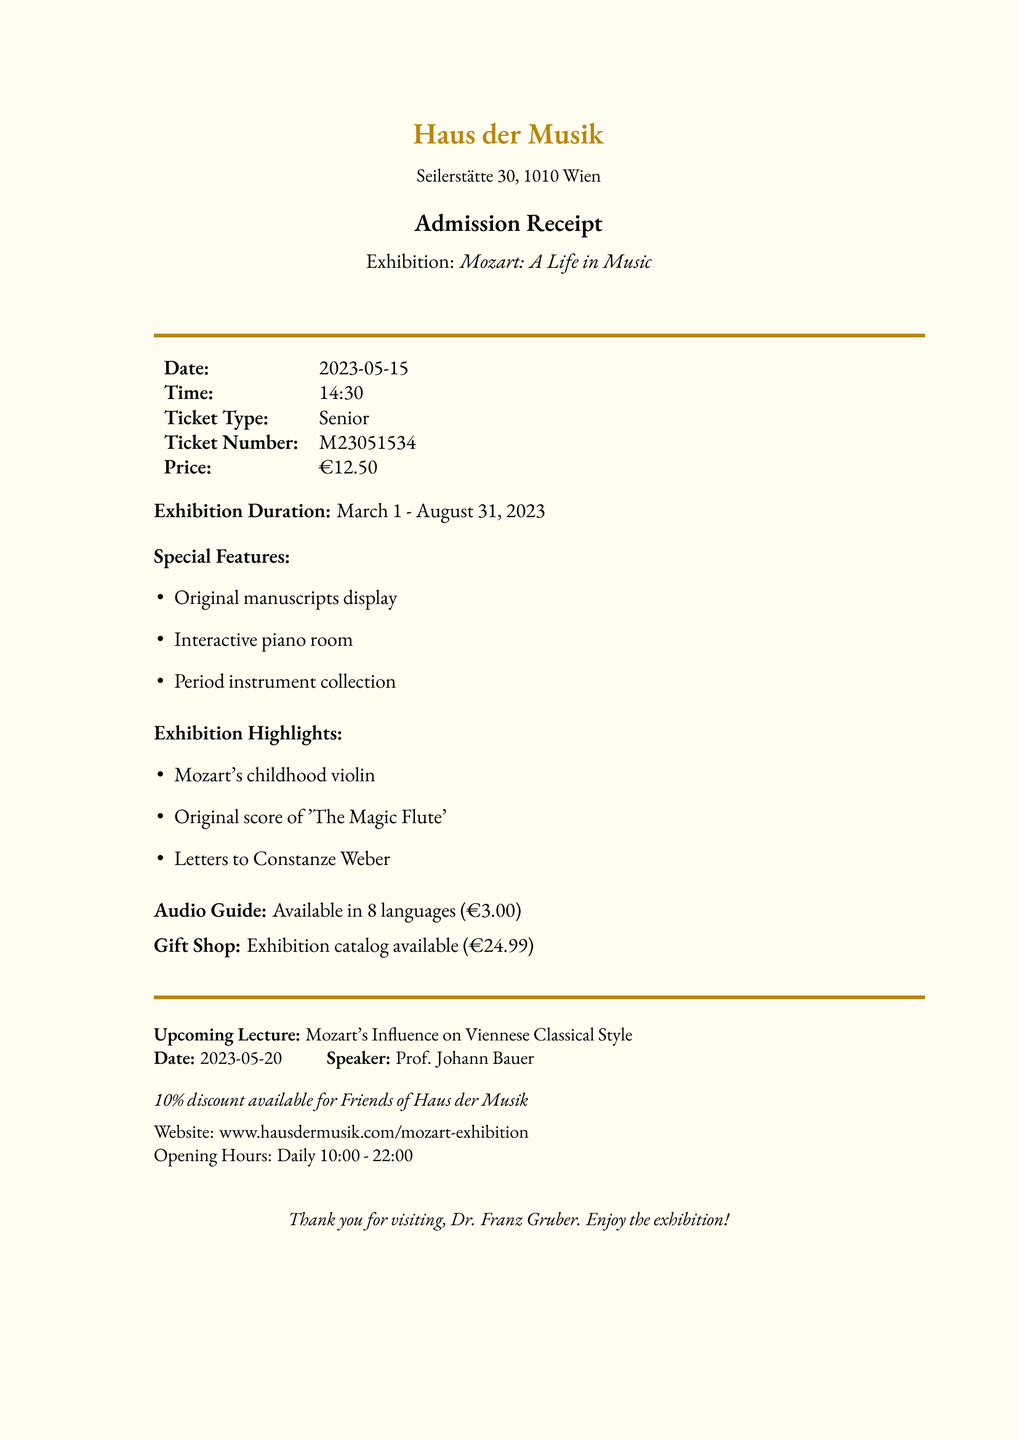What is the name of the museum? The document states the museum name in the header.
Answer: Haus der Musik What is the title of the exhibition? The exhibition title is clearly indicated in the middle of the document.
Answer: Mozart: A Life in Music When was the ticket purchased? The date of the ticket purchase is listed on the receipt.
Answer: 2023-05-15 What is the ticket number? The ticket number is provided in the details of the receipt.
Answer: M23051534 How much does the audio guide cost? The price of the audio guide is mentioned in a specific section related to audio guides.
Answer: €3.00 What is one highlight of the exhibition? The document lists several highlights of the exhibition.
Answer: Original score of 'The Magic Flute' How long is the exhibition running? The duration of the exhibition is specified in the document.
Answer: March 1 - August 31, 2023 Who is the curator of the exhibition? The curator's name is stated in the document.
Answer: Dr. Elisabeth Schumann Is there a discount for members? The document mentions a specific discount available for members.
Answer: 10% off for Friends of Haus der Musik 